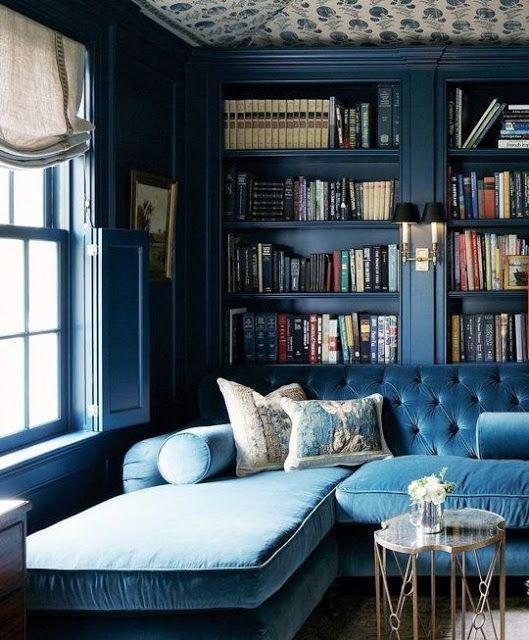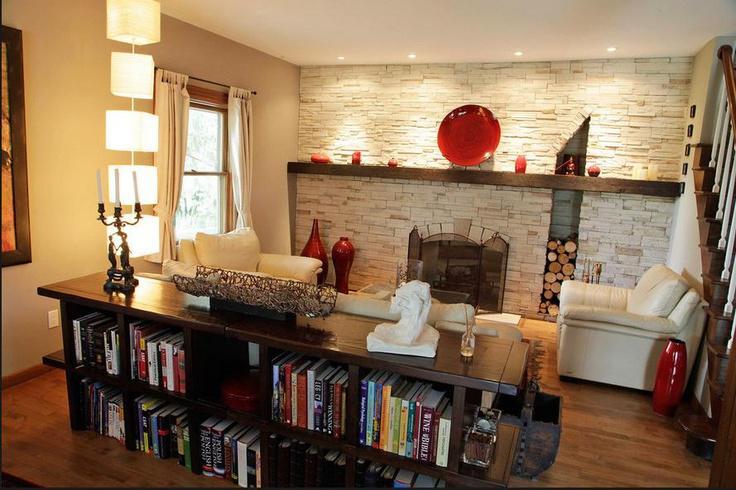The first image is the image on the left, the second image is the image on the right. Examine the images to the left and right. Is the description "A tufted royal blue sofa is in front of a wall-filling bookcase that is not white." accurate? Answer yes or no. Yes. 